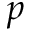Convert formula to latex. <formula><loc_0><loc_0><loc_500><loc_500>p</formula> 